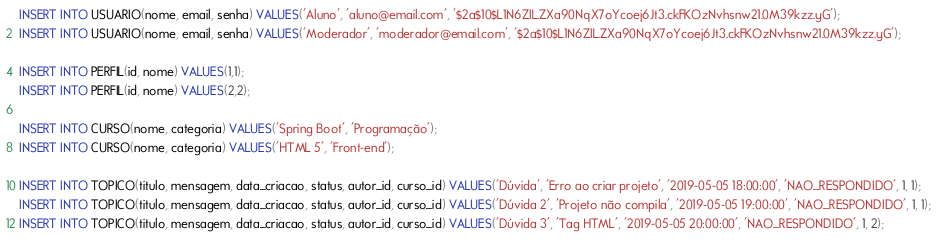Convert code to text. <code><loc_0><loc_0><loc_500><loc_500><_SQL_>INSERT INTO USUARIO(nome, email, senha) VALUES('Aluno', 'aluno@email.com', '$2a$10$L1N6ZIL.ZXa90NqX7oYcoej6Jt3.ckFKOzNvhsnw21.0M39kzz.yG');
INSERT INTO USUARIO(nome, email, senha) VALUES('Moderador', 'moderador@email.com', '$2a$10$L1N6ZIL.ZXa90NqX7oYcoej6Jt3.ckFKOzNvhsnw21.0M39kzz.yG');

INSERT INTO PERFIL(id, nome) VALUES(1,1);
INSERT INTO PERFIL(id, nome) VALUES(2,2);

INSERT INTO CURSO(nome, categoria) VALUES('Spring Boot', 'Programação');
INSERT INTO CURSO(nome, categoria) VALUES('HTML 5', 'Front-end');

INSERT INTO TOPICO(titulo, mensagem, data_criacao, status, autor_id, curso_id) VALUES('Dúvida', 'Erro ao criar projeto', '2019-05-05 18:00:00', 'NAO_RESPONDIDO', 1, 1);
INSERT INTO TOPICO(titulo, mensagem, data_criacao, status, autor_id, curso_id) VALUES('Dúvida 2', 'Projeto não compila', '2019-05-05 19:00:00', 'NAO_RESPONDIDO', 1, 1);
INSERT INTO TOPICO(titulo, mensagem, data_criacao, status, autor_id, curso_id) VALUES('Dúvida 3', 'Tag HTML', '2019-05-05 20:00:00', 'NAO_RESPONDIDO', 1, 2);</code> 